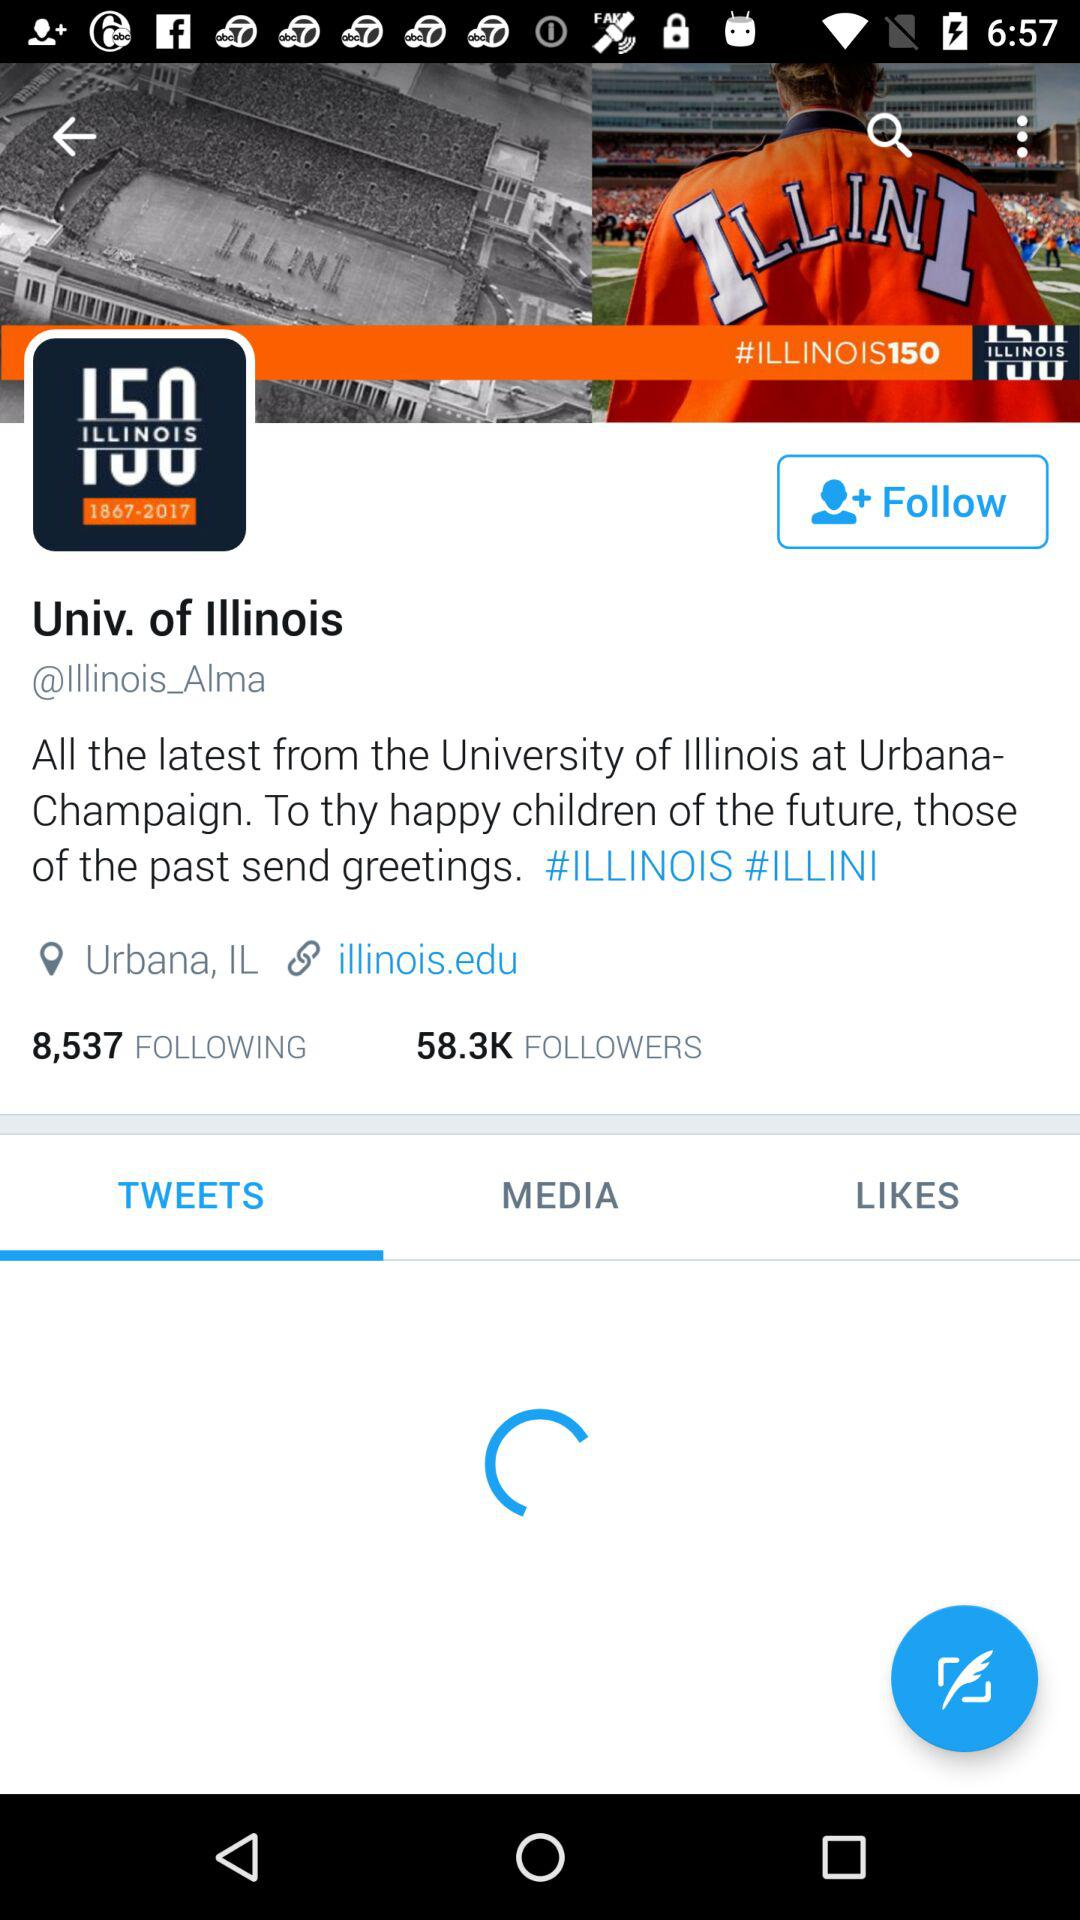How many followers does the account have?
Answer the question using a single word or phrase. 58.3K 